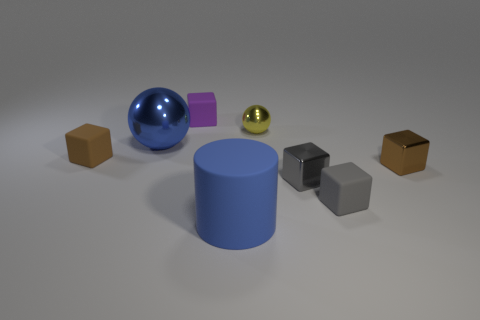What shape is the metallic object that is the same color as the large matte object?
Ensure brevity in your answer.  Sphere. Are there any gray metal things that are to the left of the big thing that is in front of the matte thing left of the small purple matte object?
Provide a succinct answer. No. Are the thing that is left of the big blue sphere and the large ball made of the same material?
Your answer should be compact. No. What color is the other small metal object that is the same shape as the small brown metallic thing?
Offer a terse response. Gray. Is there any other thing that has the same shape as the yellow thing?
Your answer should be compact. Yes. Are there an equal number of tiny brown metallic blocks that are in front of the brown shiny object and gray metallic things?
Ensure brevity in your answer.  No. Are there any tiny rubber blocks behind the purple matte thing?
Provide a short and direct response. No. There is a blue object that is to the right of the small matte block behind the object that is on the left side of the blue metal sphere; what size is it?
Your answer should be very brief. Large. There is a tiny rubber thing in front of the tiny brown rubber block; is it the same shape as the matte object behind the small yellow metallic thing?
Offer a terse response. Yes. There is a purple matte object that is the same shape as the brown metal object; what size is it?
Make the answer very short. Small. 